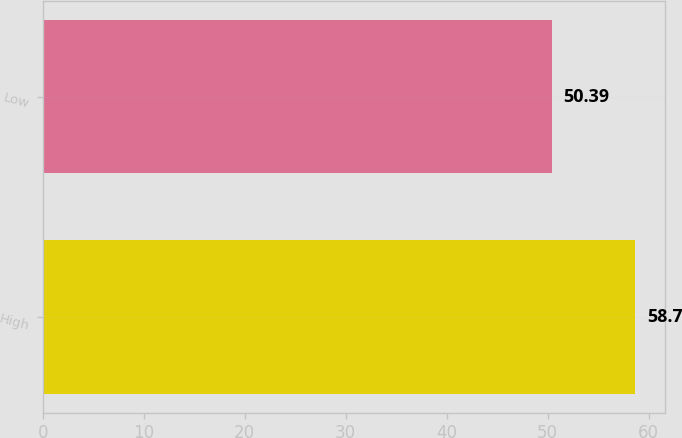Convert chart. <chart><loc_0><loc_0><loc_500><loc_500><bar_chart><fcel>High<fcel>Low<nl><fcel>58.7<fcel>50.39<nl></chart> 